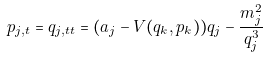<formula> <loc_0><loc_0><loc_500><loc_500>p _ { j , t } = q _ { j , t t } = ( a _ { j } - V ( q _ { k } , p _ { k } ) ) q _ { j } - \frac { m _ { j } ^ { 2 } } { q _ { j } ^ { 3 } }</formula> 